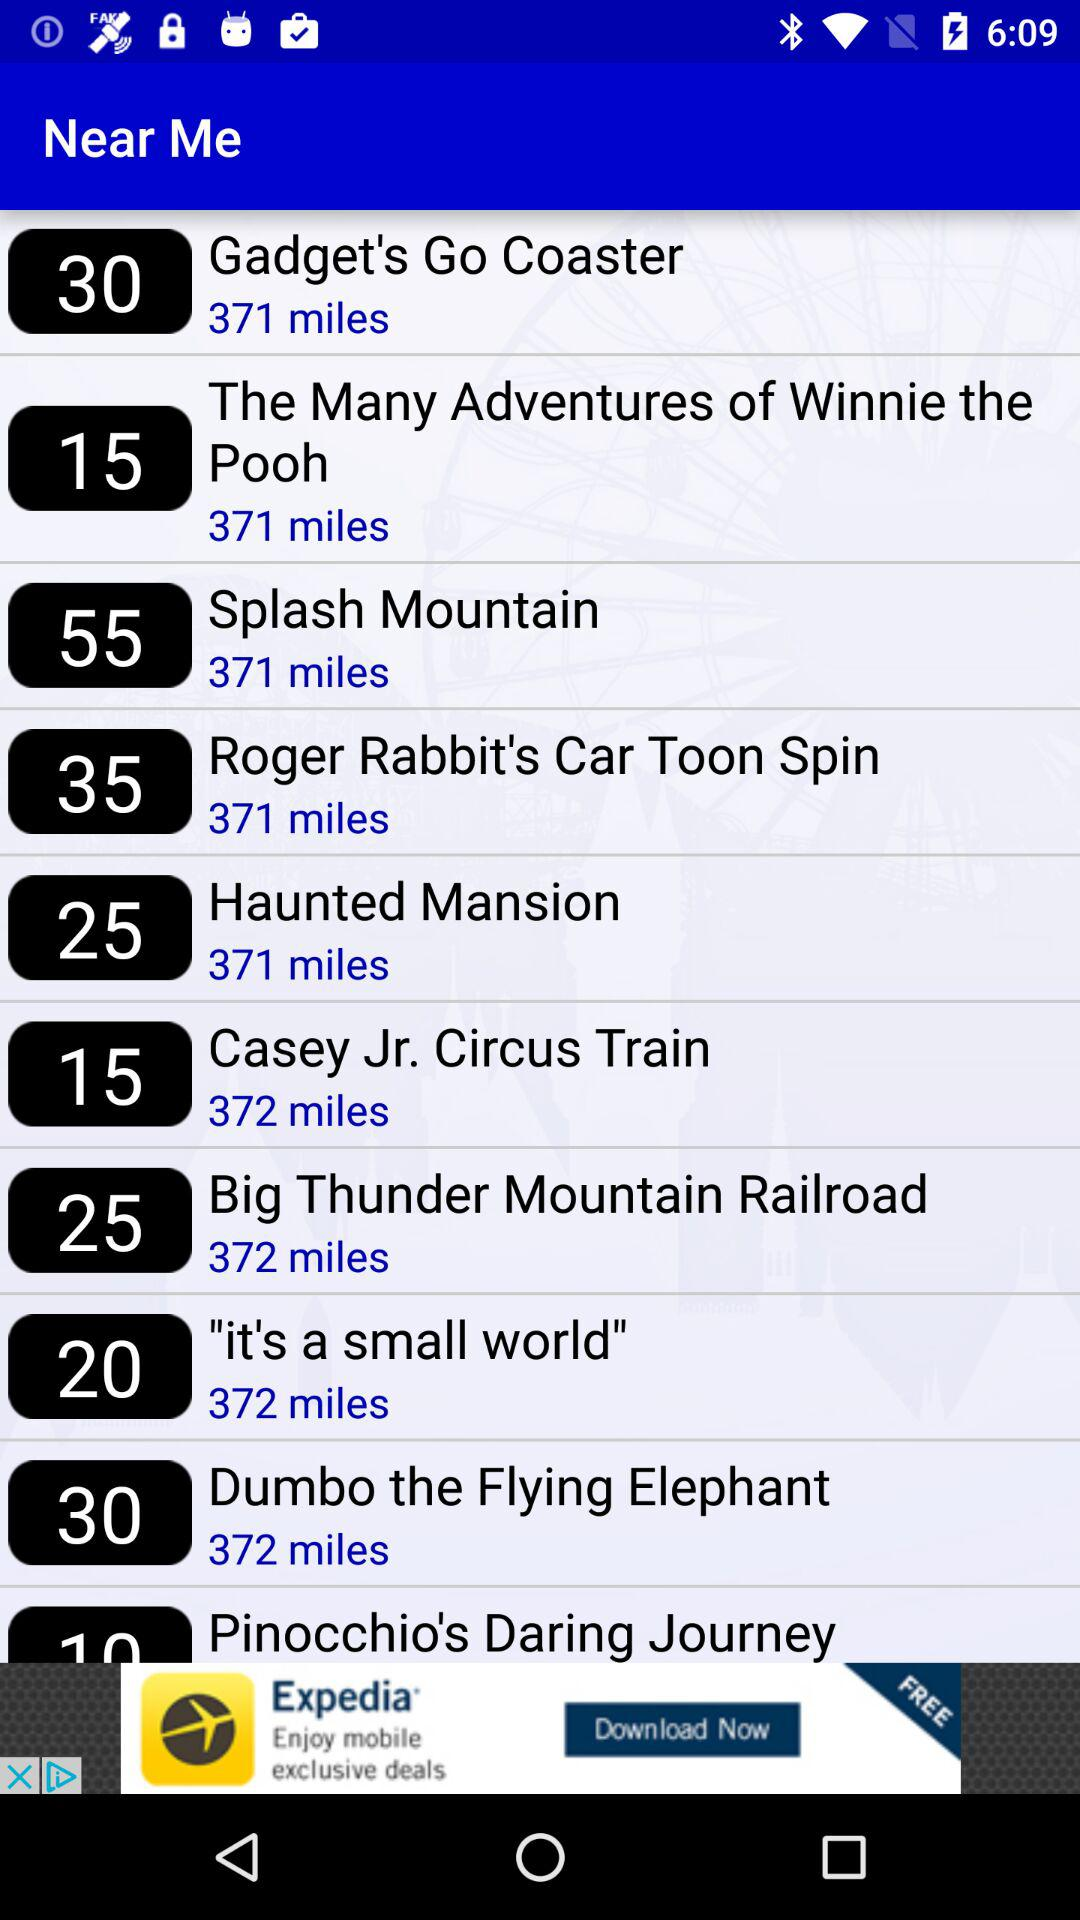How far is "Splash Mountain"? The Splash Mountain is 371 miles away. 